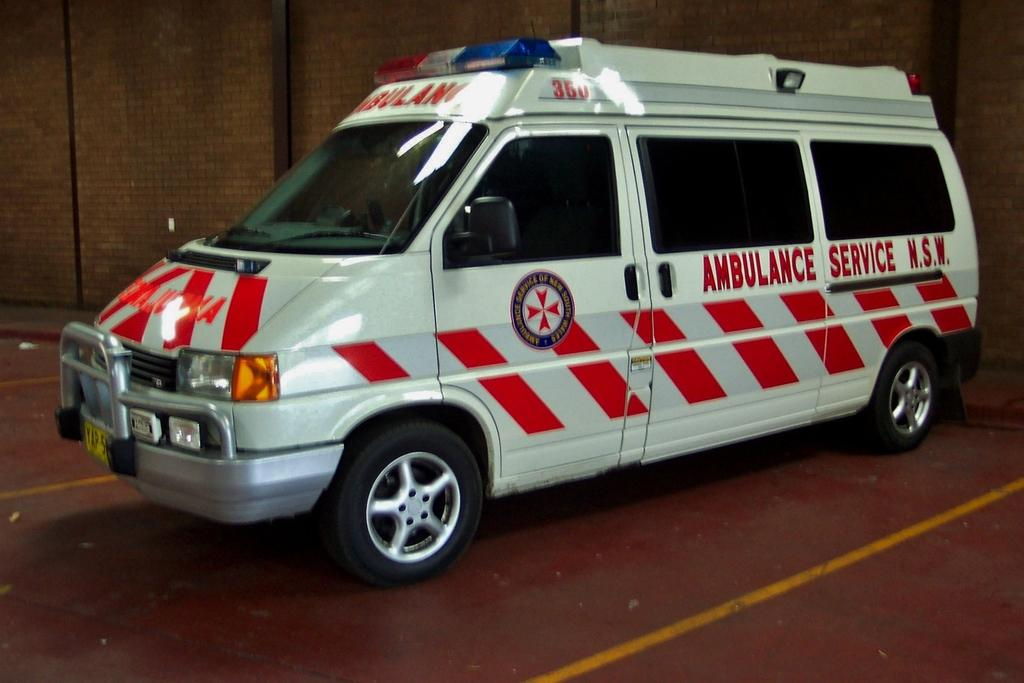Provide a one-sentence caption for the provided image. an ambulance with the words 'ambulance service N.S.W. on its side.'. 